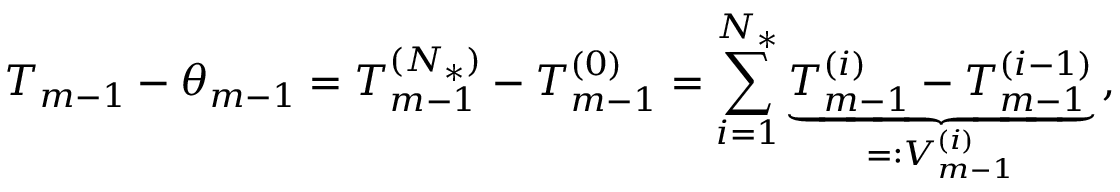Convert formula to latex. <formula><loc_0><loc_0><loc_500><loc_500>T _ { m - 1 } - \theta _ { m - 1 } = T _ { m - 1 } ^ { ( { N _ { * } } ) } - T _ { m - 1 } ^ { ( 0 ) } = \sum _ { i = 1 } ^ { { N _ { * } } } \underbrace { T _ { m - 1 } ^ { ( i ) } - T _ { m - 1 } ^ { ( i - 1 ) } } _ { = \colon V _ { m - 1 } ^ { ( i ) } } \, ,</formula> 